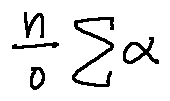<formula> <loc_0><loc_0><loc_500><loc_500>\frac { n } { o } \sum \alpha</formula> 